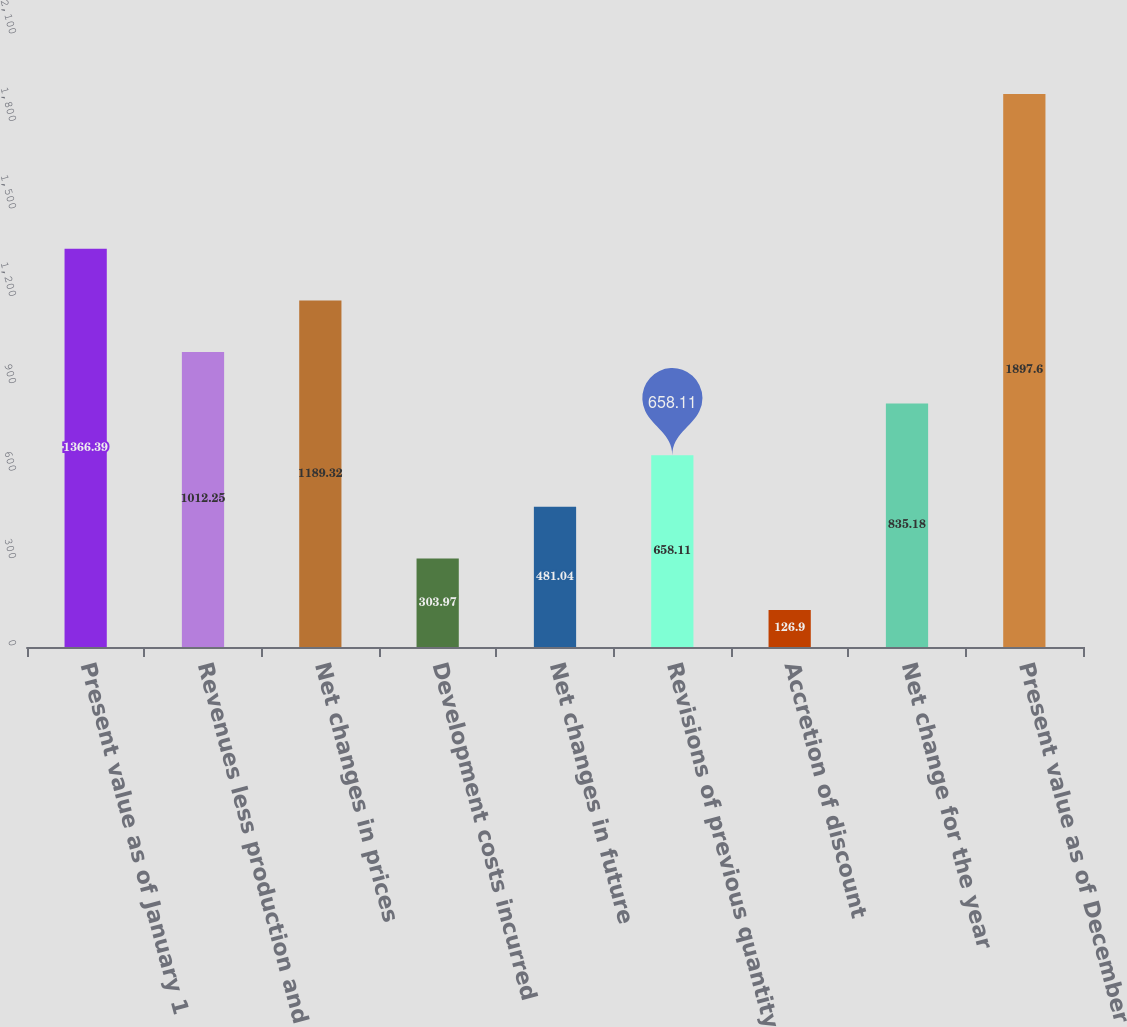Convert chart. <chart><loc_0><loc_0><loc_500><loc_500><bar_chart><fcel>Present value as of January 1<fcel>Revenues less production and<fcel>Net changes in prices<fcel>Development costs incurred<fcel>Net changes in future<fcel>Revisions of previous quantity<fcel>Accretion of discount<fcel>Net change for the year<fcel>Present value as of December<nl><fcel>1366.39<fcel>1012.25<fcel>1189.32<fcel>303.97<fcel>481.04<fcel>658.11<fcel>126.9<fcel>835.18<fcel>1897.6<nl></chart> 